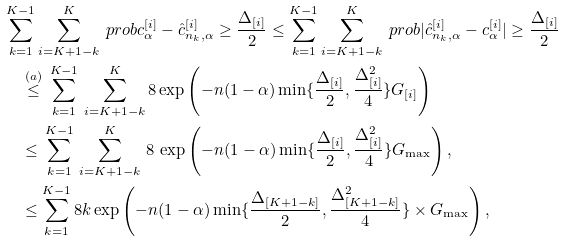Convert formula to latex. <formula><loc_0><loc_0><loc_500><loc_500>& \sum _ { k = 1 } ^ { K - 1 } \sum _ { i = K + 1 - k } ^ { K } \ p r o b { c ^ { [ i ] } _ { \alpha } - \hat { c } ^ { [ i ] } _ { { n _ { k } } , \alpha } \geq \frac { \Delta _ { [ i ] } } { 2 } } \leq \sum _ { k = 1 } ^ { K - 1 } \sum _ { i = K + 1 - k } ^ { K } \ p r o b { | \hat { c } ^ { [ i ] } _ { { n _ { k } } , \alpha } - c ^ { [ i ] } _ { \alpha } | \geq \frac { \Delta _ { [ i ] } } { 2 } } \\ & \quad \overset { ( a ) } { \leq } \, \sum _ { k = 1 } ^ { K - 1 } \, \sum _ { i = K + 1 - k } ^ { K } 8 \exp \left ( - n ( 1 - \alpha ) \min \{ \frac { \Delta _ { [ i ] } } { 2 } , \frac { \Delta _ { [ i ] } ^ { 2 } } { 4 } \} G _ { [ i ] } \right ) \\ & \quad \leq \, \sum _ { k = 1 } ^ { K - 1 } \, \sum _ { i = K + 1 - k } ^ { K } \, 8 \, \exp \left ( - n ( 1 - \alpha ) \min \{ \frac { \Delta _ { [ i ] } } { 2 } , \frac { \Delta _ { [ i ] } ^ { 2 } } { 4 } \} G _ { \max } \right ) , \\ & \quad \leq \sum _ { k = 1 } ^ { K - 1 } 8 k \exp \left ( - n ( 1 - \alpha ) \min \{ \frac { \Delta _ { [ K + 1 - k ] } } { 2 } , \frac { \Delta _ { [ K + 1 - k ] } ^ { 2 } } { 4 } \} \times G _ { \max } \right ) ,</formula> 